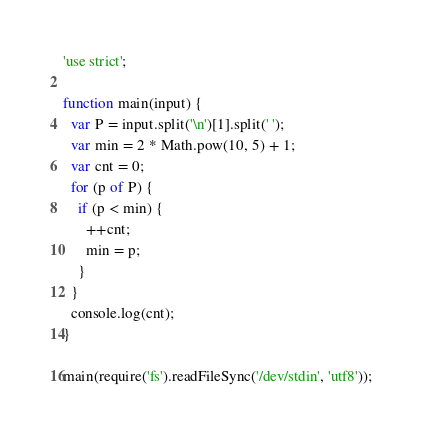Convert code to text. <code><loc_0><loc_0><loc_500><loc_500><_JavaScript_>'use strict';

function main(input) {
  var P = input.split('\n')[1].split(' ');
  var min = 2 * Math.pow(10, 5) + 1;
  var cnt = 0;
  for (p of P) {
    if (p < min) {
      ++cnt;
      min = p;
    }
  }
  console.log(cnt);
}

main(require('fs').readFileSync('/dev/stdin', 'utf8'));</code> 